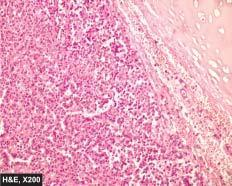re these nests composed of uniform cuboidal cells having granular cytoplasm?
Answer the question using a single word or phrase. Yes 